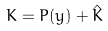<formula> <loc_0><loc_0><loc_500><loc_500>K = P ( y ) + \hat { K }</formula> 